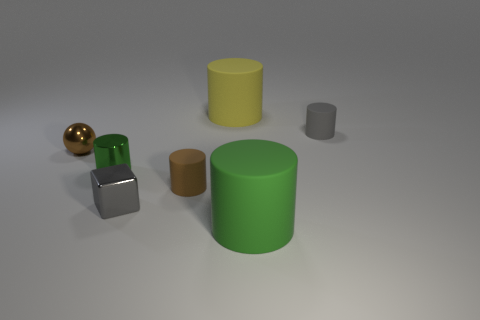What color is the metallic ball?
Make the answer very short. Brown. Do the big thing that is in front of the shiny ball and the small gray rubber thing have the same shape?
Make the answer very short. Yes. How many objects are either tiny gray metal cubes or things that are on the left side of the yellow rubber cylinder?
Provide a short and direct response. 4. Do the green object to the left of the tiny block and the tiny brown cylinder have the same material?
Provide a short and direct response. No. The green thing to the left of the large matte thing behind the small green shiny object is made of what material?
Offer a very short reply. Metal. Are there more brown objects that are to the left of the small metal cylinder than metal cylinders on the left side of the tiny metal ball?
Your answer should be compact. Yes. What is the size of the metallic ball?
Your response must be concise. Small. There is a big thing in front of the green shiny cylinder; is its color the same as the metallic cylinder?
Give a very brief answer. Yes. Are there any other things that have the same shape as the brown metallic thing?
Give a very brief answer. No. Is there a green thing that is left of the large thing that is in front of the tiny metallic cylinder?
Your response must be concise. Yes. 